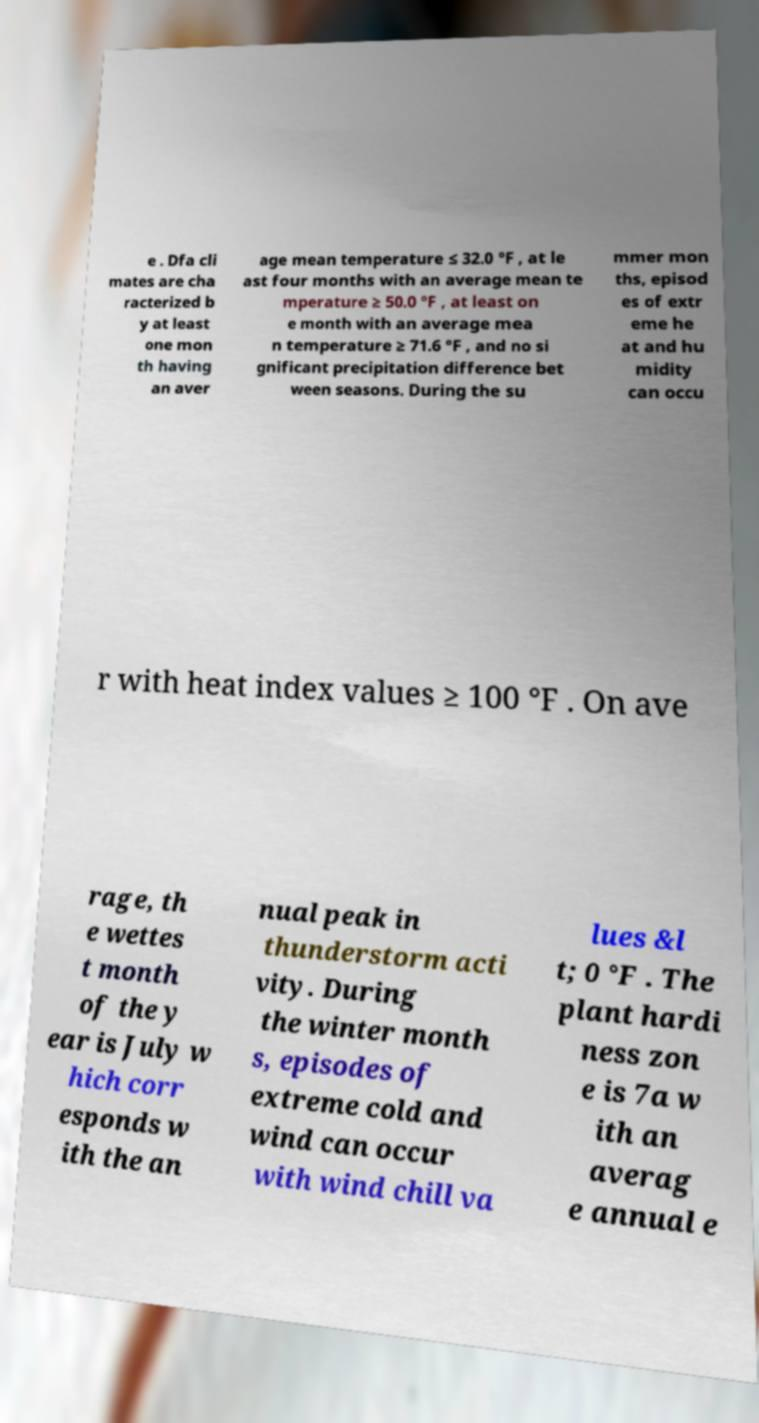Can you accurately transcribe the text from the provided image for me? e . Dfa cli mates are cha racterized b y at least one mon th having an aver age mean temperature ≤ 32.0 °F , at le ast four months with an average mean te mperature ≥ 50.0 °F , at least on e month with an average mea n temperature ≥ 71.6 °F , and no si gnificant precipitation difference bet ween seasons. During the su mmer mon ths, episod es of extr eme he at and hu midity can occu r with heat index values ≥ 100 °F . On ave rage, th e wettes t month of the y ear is July w hich corr esponds w ith the an nual peak in thunderstorm acti vity. During the winter month s, episodes of extreme cold and wind can occur with wind chill va lues &l t; 0 °F . The plant hardi ness zon e is 7a w ith an averag e annual e 